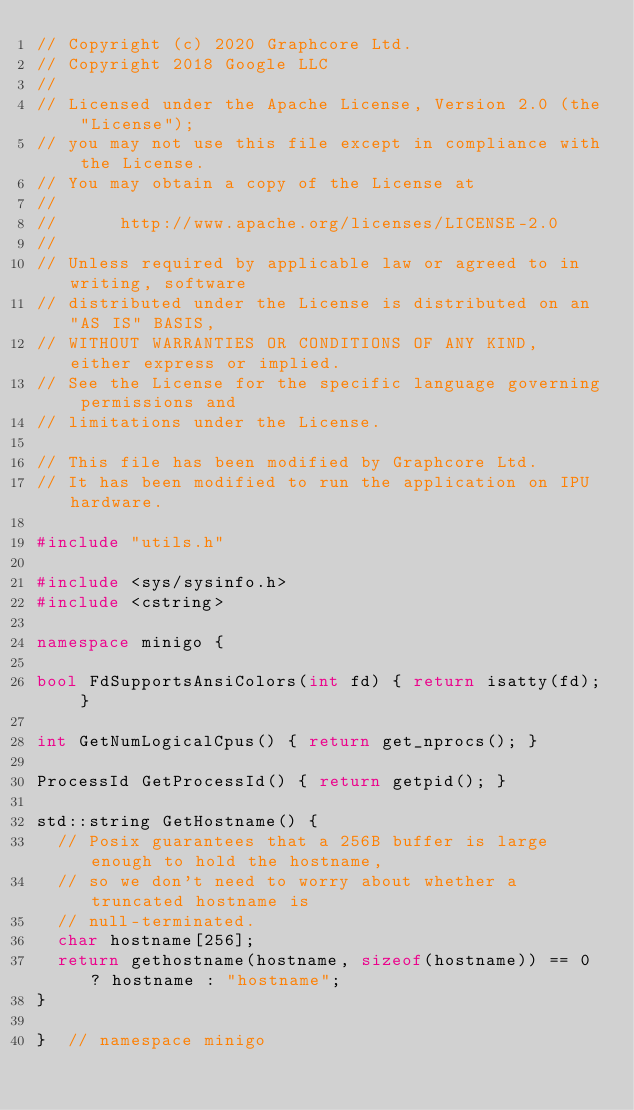Convert code to text. <code><loc_0><loc_0><loc_500><loc_500><_C++_>// Copyright (c) 2020 Graphcore Ltd.
// Copyright 2018 Google LLC
//
// Licensed under the Apache License, Version 2.0 (the "License");
// you may not use this file except in compliance with the License.
// You may obtain a copy of the License at
//
//      http://www.apache.org/licenses/LICENSE-2.0
//
// Unless required by applicable law or agreed to in writing, software
// distributed under the License is distributed on an "AS IS" BASIS,
// WITHOUT WARRANTIES OR CONDITIONS OF ANY KIND, either express or implied.
// See the License for the specific language governing permissions and
// limitations under the License.

// This file has been modified by Graphcore Ltd.
// It has been modified to run the application on IPU hardware.

#include "utils.h"

#include <sys/sysinfo.h>
#include <cstring>

namespace minigo {

bool FdSupportsAnsiColors(int fd) { return isatty(fd); }

int GetNumLogicalCpus() { return get_nprocs(); }

ProcessId GetProcessId() { return getpid(); }

std::string GetHostname() {
  // Posix guarantees that a 256B buffer is large enough to hold the hostname,
  // so we don't need to worry about whether a truncated hostname is
  // null-terminated.
  char hostname[256];
  return gethostname(hostname, sizeof(hostname)) == 0 ? hostname : "hostname";
}

}  // namespace minigo
</code> 